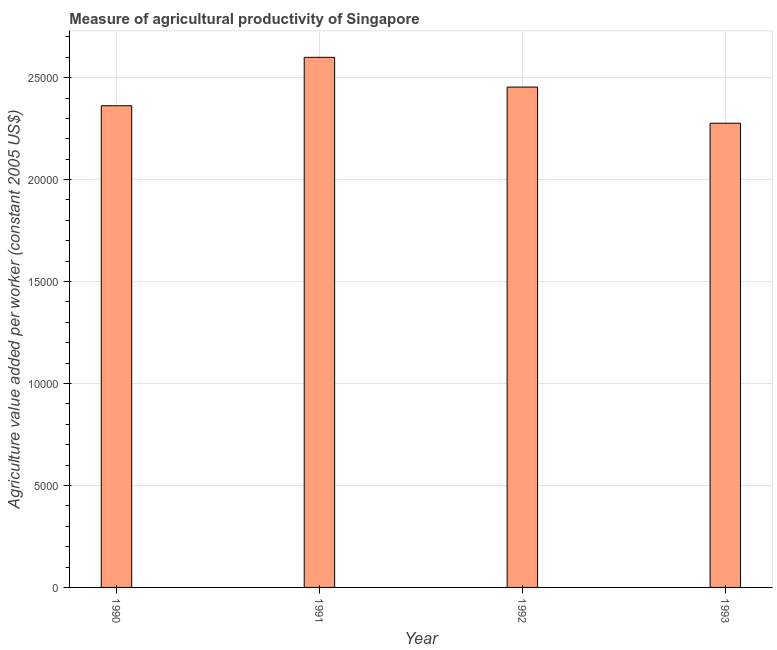Does the graph contain any zero values?
Offer a terse response. No. What is the title of the graph?
Provide a short and direct response. Measure of agricultural productivity of Singapore. What is the label or title of the Y-axis?
Keep it short and to the point. Agriculture value added per worker (constant 2005 US$). What is the agriculture value added per worker in 1991?
Offer a terse response. 2.60e+04. Across all years, what is the maximum agriculture value added per worker?
Provide a short and direct response. 2.60e+04. Across all years, what is the minimum agriculture value added per worker?
Ensure brevity in your answer.  2.28e+04. In which year was the agriculture value added per worker maximum?
Offer a terse response. 1991. In which year was the agriculture value added per worker minimum?
Provide a succinct answer. 1993. What is the sum of the agriculture value added per worker?
Offer a very short reply. 9.69e+04. What is the difference between the agriculture value added per worker in 1990 and 1991?
Your answer should be compact. -2373.34. What is the average agriculture value added per worker per year?
Provide a short and direct response. 2.42e+04. What is the median agriculture value added per worker?
Your answer should be compact. 2.41e+04. In how many years, is the agriculture value added per worker greater than 12000 US$?
Make the answer very short. 4. What is the ratio of the agriculture value added per worker in 1992 to that in 1993?
Offer a very short reply. 1.08. Is the agriculture value added per worker in 1990 less than that in 1993?
Give a very brief answer. No. What is the difference between the highest and the second highest agriculture value added per worker?
Make the answer very short. 1458.97. Is the sum of the agriculture value added per worker in 1992 and 1993 greater than the maximum agriculture value added per worker across all years?
Ensure brevity in your answer.  Yes. What is the difference between the highest and the lowest agriculture value added per worker?
Make the answer very short. 3231.45. How many bars are there?
Your response must be concise. 4. How many years are there in the graph?
Provide a succinct answer. 4. What is the difference between two consecutive major ticks on the Y-axis?
Your answer should be very brief. 5000. Are the values on the major ticks of Y-axis written in scientific E-notation?
Provide a succinct answer. No. What is the Agriculture value added per worker (constant 2005 US$) of 1990?
Offer a very short reply. 2.36e+04. What is the Agriculture value added per worker (constant 2005 US$) of 1991?
Your response must be concise. 2.60e+04. What is the Agriculture value added per worker (constant 2005 US$) in 1992?
Keep it short and to the point. 2.45e+04. What is the Agriculture value added per worker (constant 2005 US$) in 1993?
Provide a short and direct response. 2.28e+04. What is the difference between the Agriculture value added per worker (constant 2005 US$) in 1990 and 1991?
Provide a short and direct response. -2373.34. What is the difference between the Agriculture value added per worker (constant 2005 US$) in 1990 and 1992?
Make the answer very short. -914.37. What is the difference between the Agriculture value added per worker (constant 2005 US$) in 1990 and 1993?
Make the answer very short. 858.1. What is the difference between the Agriculture value added per worker (constant 2005 US$) in 1991 and 1992?
Keep it short and to the point. 1458.97. What is the difference between the Agriculture value added per worker (constant 2005 US$) in 1991 and 1993?
Make the answer very short. 3231.45. What is the difference between the Agriculture value added per worker (constant 2005 US$) in 1992 and 1993?
Your answer should be compact. 1772.47. What is the ratio of the Agriculture value added per worker (constant 2005 US$) in 1990 to that in 1991?
Make the answer very short. 0.91. What is the ratio of the Agriculture value added per worker (constant 2005 US$) in 1990 to that in 1993?
Ensure brevity in your answer.  1.04. What is the ratio of the Agriculture value added per worker (constant 2005 US$) in 1991 to that in 1992?
Offer a very short reply. 1.06. What is the ratio of the Agriculture value added per worker (constant 2005 US$) in 1991 to that in 1993?
Ensure brevity in your answer.  1.14. What is the ratio of the Agriculture value added per worker (constant 2005 US$) in 1992 to that in 1993?
Ensure brevity in your answer.  1.08. 